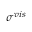<formula> <loc_0><loc_0><loc_500><loc_500>\sigma ^ { v i s }</formula> 